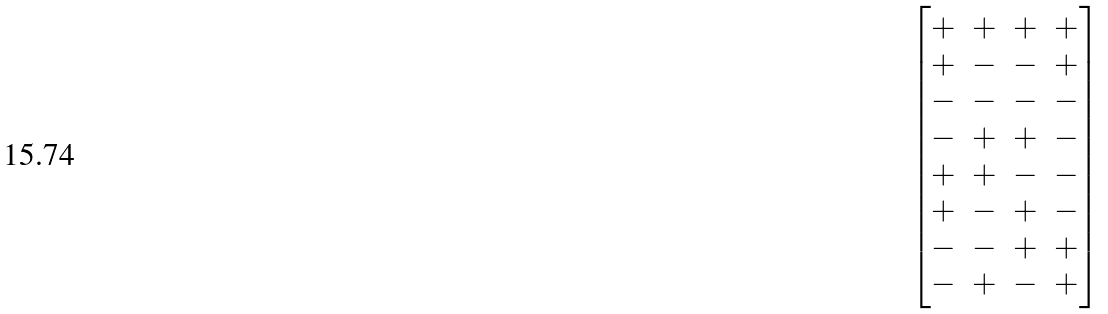<formula> <loc_0><loc_0><loc_500><loc_500>\begin{bmatrix} + & + & + & + \\ + & - & - & + \\ - & - & - & - \\ - & + & + & - \\ + & + & - & - \\ + & - & + & - \\ - & - & + & + \\ - & + & - & + \\ \end{bmatrix}</formula> 